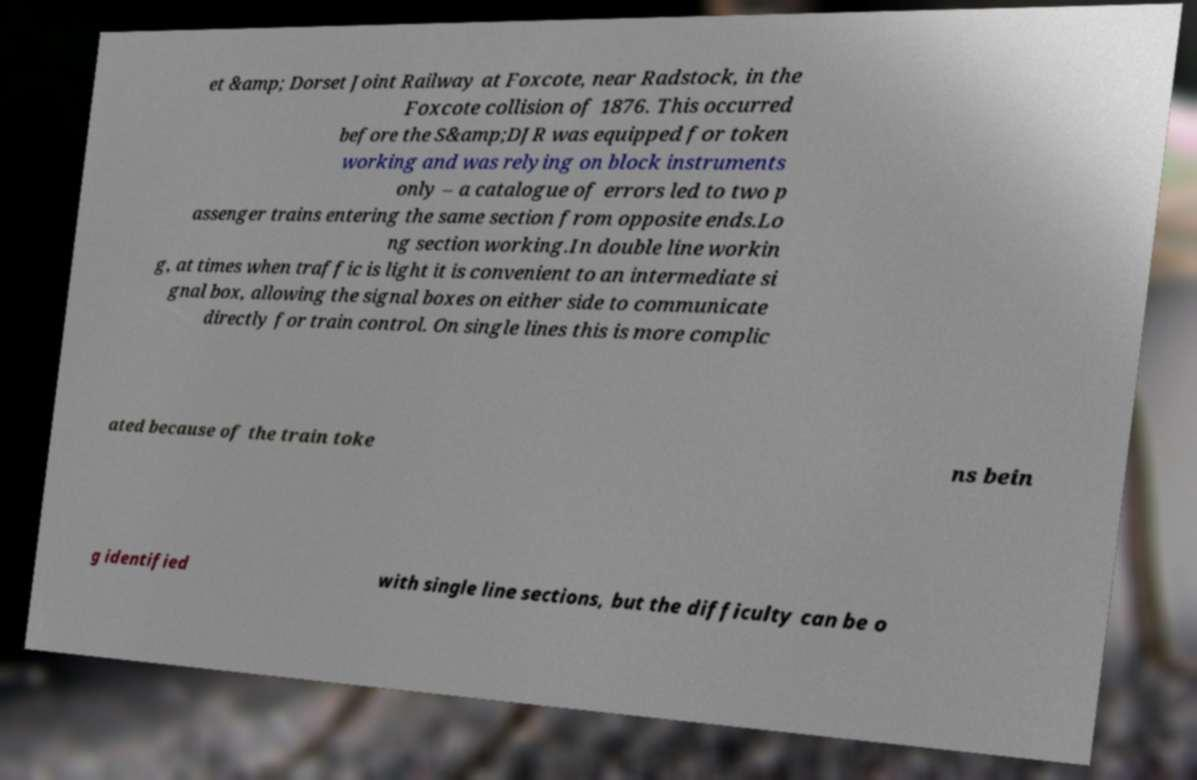Could you assist in decoding the text presented in this image and type it out clearly? et &amp; Dorset Joint Railway at Foxcote, near Radstock, in the Foxcote collision of 1876. This occurred before the S&amp;DJR was equipped for token working and was relying on block instruments only – a catalogue of errors led to two p assenger trains entering the same section from opposite ends.Lo ng section working.In double line workin g, at times when traffic is light it is convenient to an intermediate si gnal box, allowing the signal boxes on either side to communicate directly for train control. On single lines this is more complic ated because of the train toke ns bein g identified with single line sections, but the difficulty can be o 